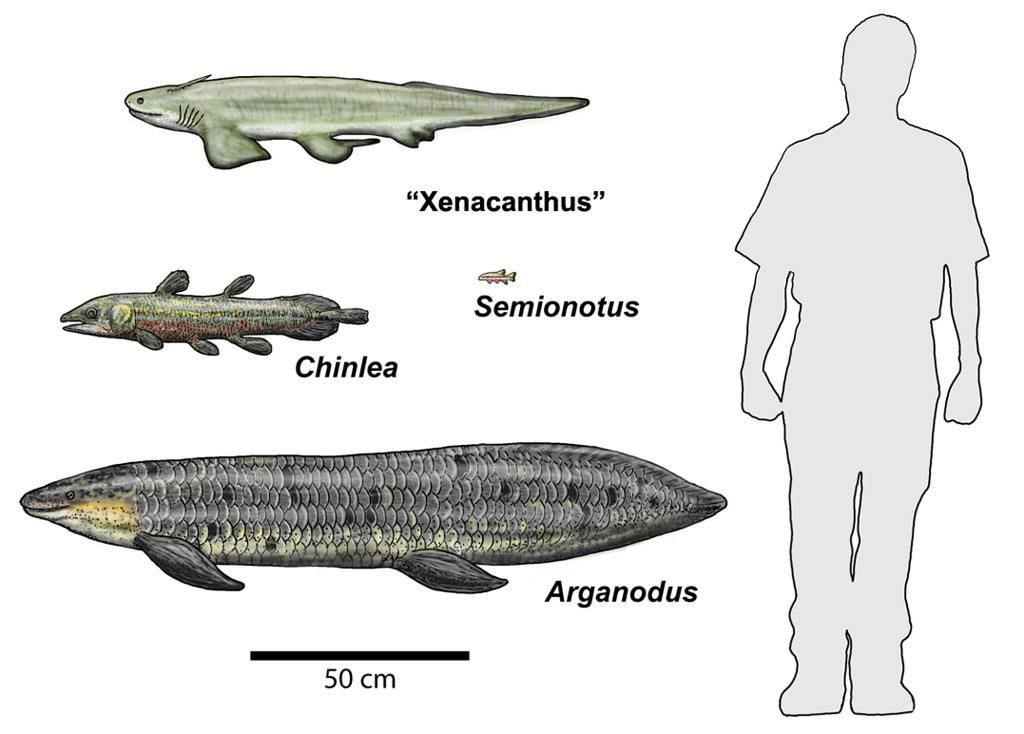What type of animals can be seen in the image? There are fishes in the image. What is located on the right side of the image? A: There is a drawing of a person on the right side of the image. What else can be found in the image besides the fishes and the drawing? There is text in the image. What type of argument can be seen in the image? There is no argument present in the image; it features fishes, a drawing of a person, and text. What kind of hole can be seen in the image? There is no hole present in the image. 